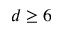<formula> <loc_0><loc_0><loc_500><loc_500>d \geq 6</formula> 